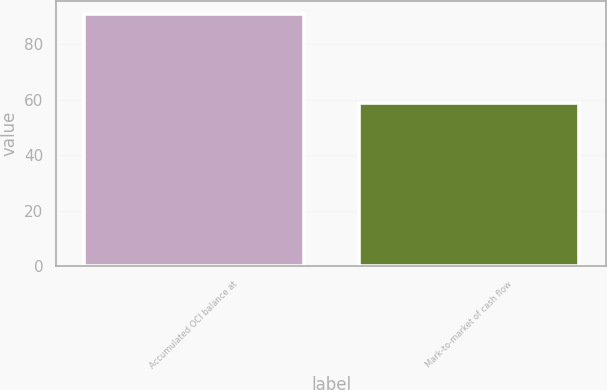Convert chart to OTSL. <chart><loc_0><loc_0><loc_500><loc_500><bar_chart><fcel>Accumulated OCI balance at<fcel>Mark-to-market of cash flow<nl><fcel>91<fcel>59<nl></chart> 